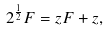<formula> <loc_0><loc_0><loc_500><loc_500>2 ^ { \frac { 1 } { 2 } } F = z F + z ,</formula> 